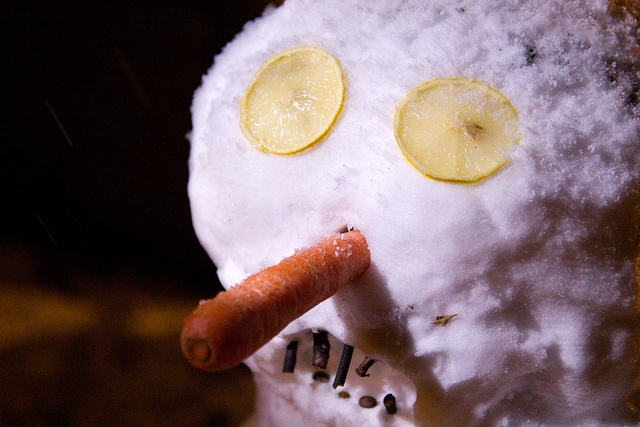Describe the objects in this image and their specific colors. I can see a carrot in black, maroon, and brown tones in this image. 